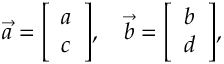Convert formula to latex. <formula><loc_0><loc_0><loc_500><loc_500>{ \overrightarrow { a } } = { \left [ \begin{array} { l } { a } \\ { c } \end{array} \right ] } , \quad \overrightarrow { b } = { \left [ \begin{array} { l } { b } \\ { d } \end{array} \right ] } ,</formula> 